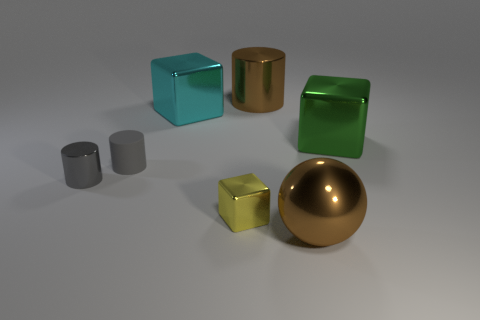Add 1 tiny rubber things. How many objects exist? 8 Subtract all blocks. How many objects are left? 4 Add 3 yellow shiny blocks. How many yellow shiny blocks are left? 4 Add 7 balls. How many balls exist? 8 Subtract 0 green cylinders. How many objects are left? 7 Subtract all large red rubber spheres. Subtract all yellow shiny cubes. How many objects are left? 6 